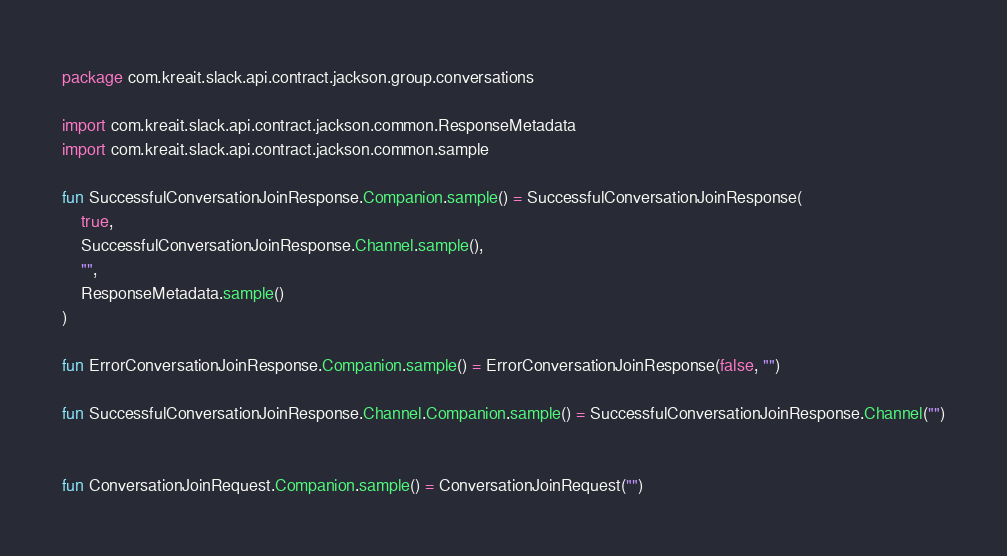<code> <loc_0><loc_0><loc_500><loc_500><_Kotlin_>package com.kreait.slack.api.contract.jackson.group.conversations

import com.kreait.slack.api.contract.jackson.common.ResponseMetadata
import com.kreait.slack.api.contract.jackson.common.sample

fun SuccessfulConversationJoinResponse.Companion.sample() = SuccessfulConversationJoinResponse(
    true,
    SuccessfulConversationJoinResponse.Channel.sample(),
    "",
    ResponseMetadata.sample()
)

fun ErrorConversationJoinResponse.Companion.sample() = ErrorConversationJoinResponse(false, "")

fun SuccessfulConversationJoinResponse.Channel.Companion.sample() = SuccessfulConversationJoinResponse.Channel("")


fun ConversationJoinRequest.Companion.sample() = ConversationJoinRequest("")

</code> 